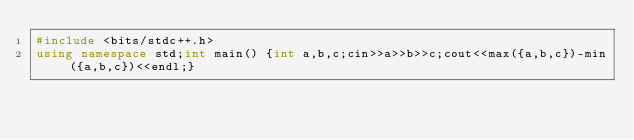<code> <loc_0><loc_0><loc_500><loc_500><_C++_>#include <bits/stdc++.h>
using namespace std;int main() {int a,b,c;cin>>a>>b>>c;cout<<max({a,b,c})-min({a,b,c})<<endl;}</code> 